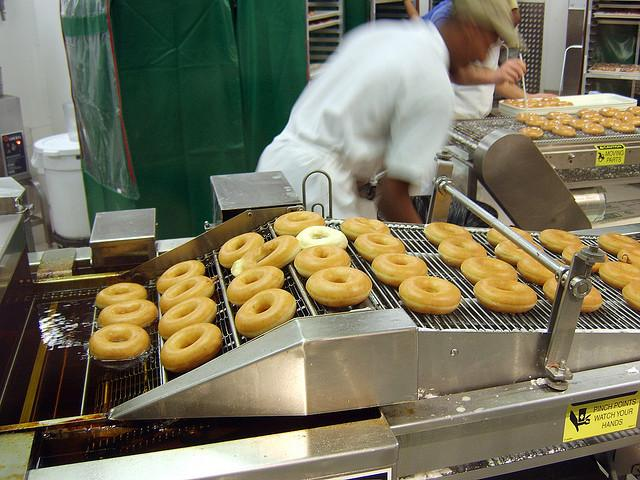What type of job are the men doing? baking 